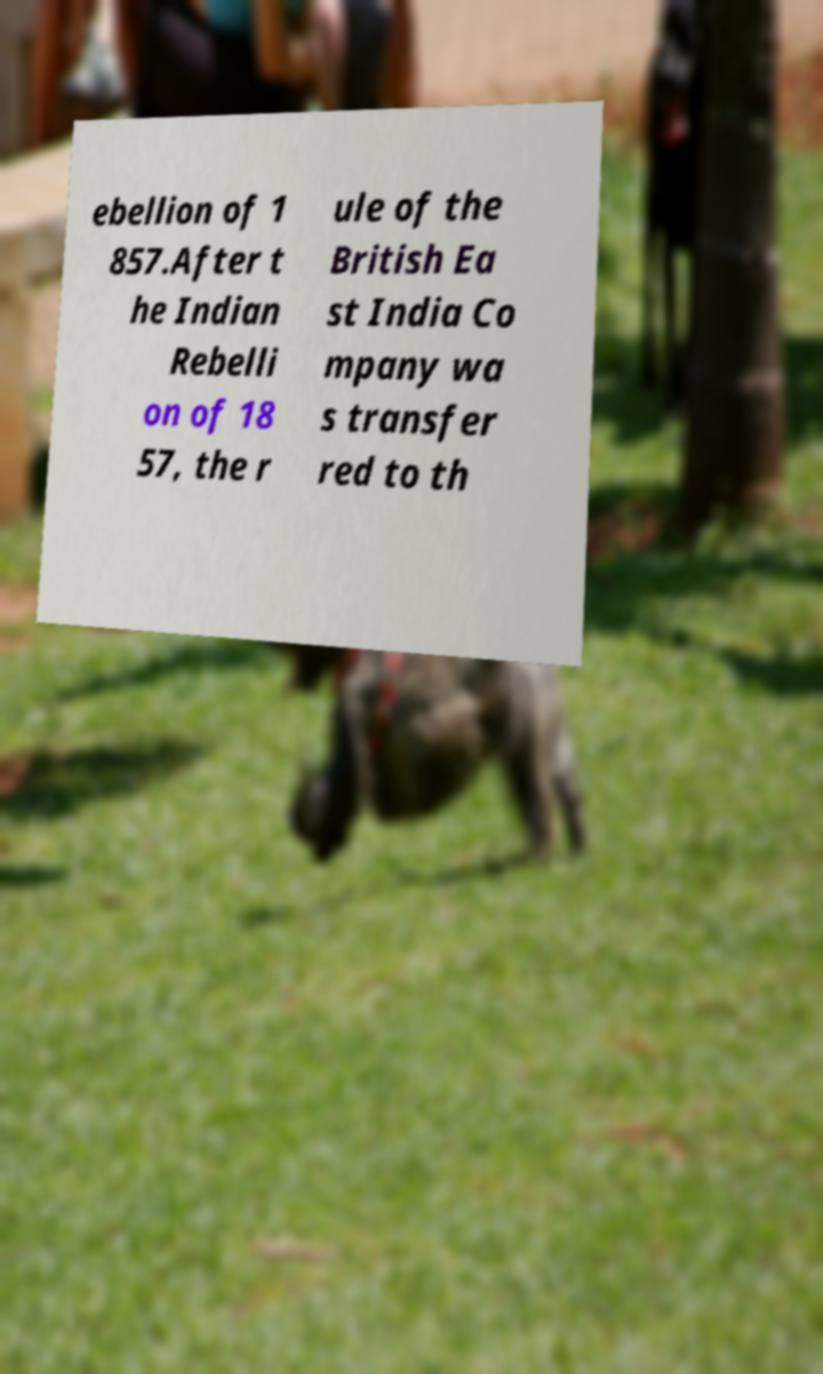I need the written content from this picture converted into text. Can you do that? ebellion of 1 857.After t he Indian Rebelli on of 18 57, the r ule of the British Ea st India Co mpany wa s transfer red to th 